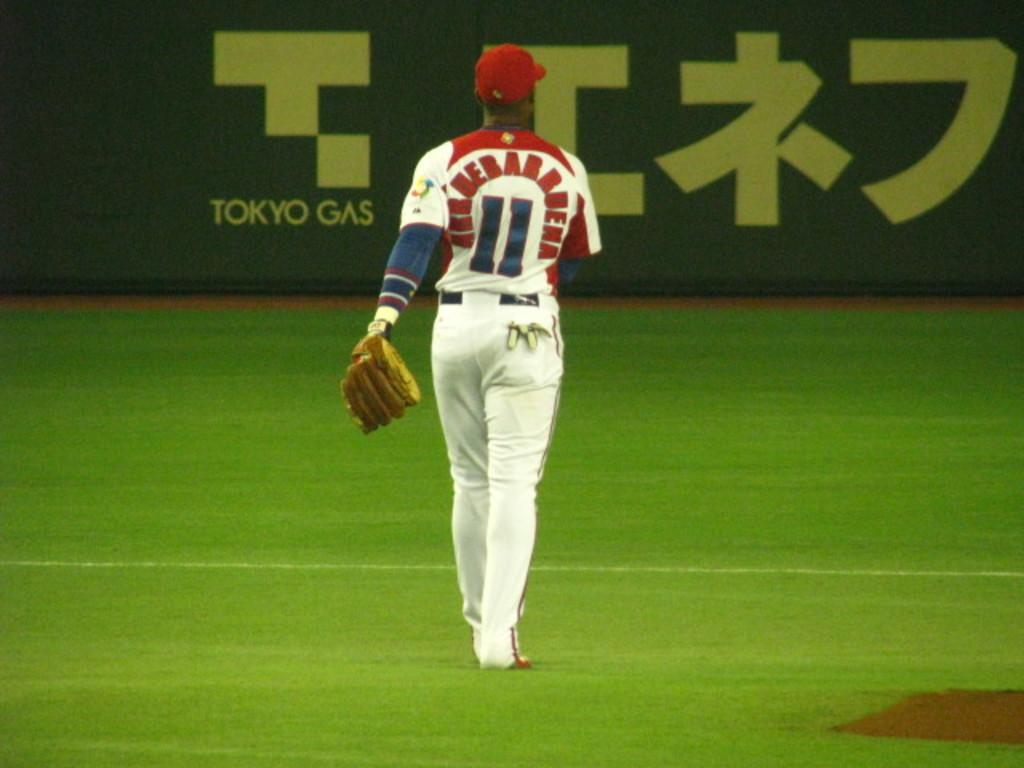Provide a one-sentence caption for the provided image. A baseball player with the number 11 on his jersey is walking the field. 